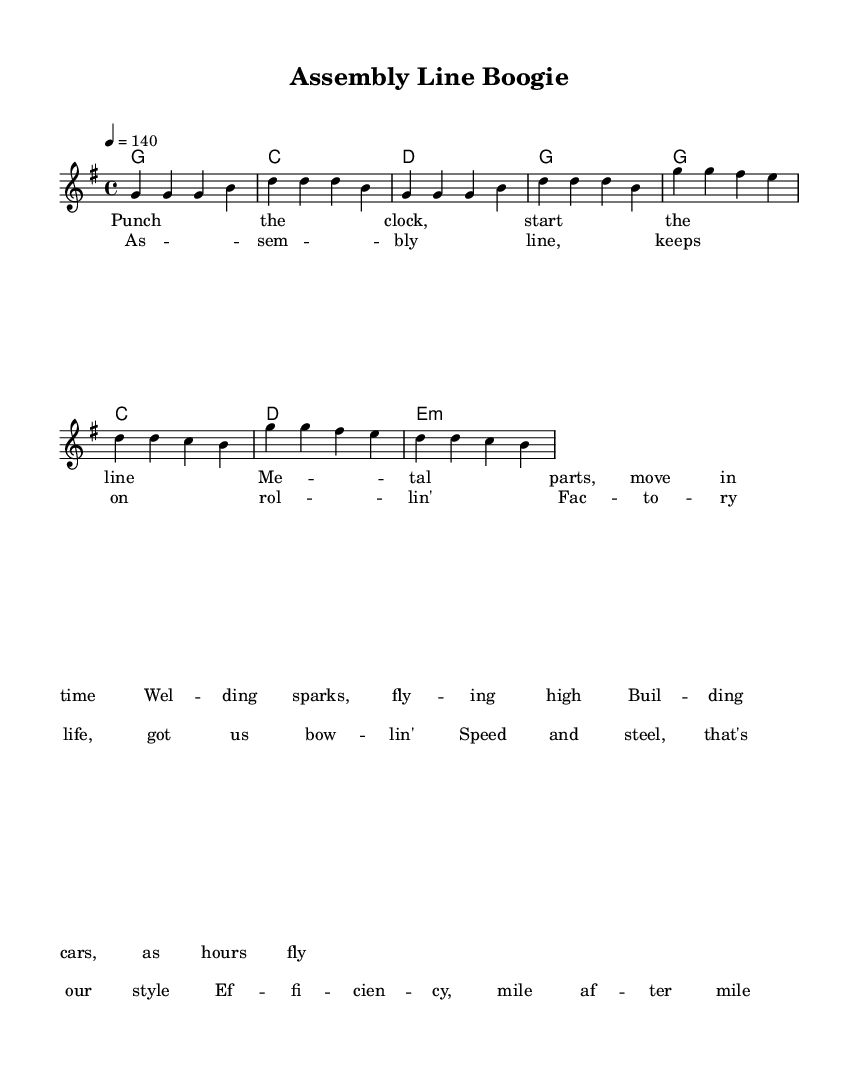What is the key signature of this music? The key signature is G major, which has one sharp (F#). This is indicated at the beginning of the staff where the sharps are marked.
Answer: G major What is the time signature of the piece? The time signature is 4/4, shown at the beginning of the score, indicating that there are four beats per measure and that the quarter note receives one beat.
Answer: 4/4 What is the tempo marking for the piece? The tempo marking is 140 beats per minute, which is indicated using a metronome marking at the beginning of the score and shows the intended speed.
Answer: 140 How many bars are there in the verse? The verse contains 8 bars, as counted from the beginning of the verse section to the end. Each group of notes separated by vertical lines represents one bar.
Answer: 8 How does the chorus differ in structure from the verse? The chorus has a different melody and lyrical rhythm, changing the musical phrasing, and maintains a similar chord progression but with a slight variation, indicating a shift in the musical narrative.
Answer: Varies in melody What thematic elements are present in the lyrics? The lyrics discuss assembly line work, speed, and efficiency, reflecting the life of factory workers, which is a common theme for Country Rock music focusing on working class narratives.
Answer: Factory life What is the overall mood of the song as indicated by the tempo and lyrics? The overall mood is upbeat and energetic, as indicated by the fast tempo and the positive, industrious nature of the lyrics celebrating factory life and efficiency, typical of Country Rock's lively spirit.
Answer: Upbeat 